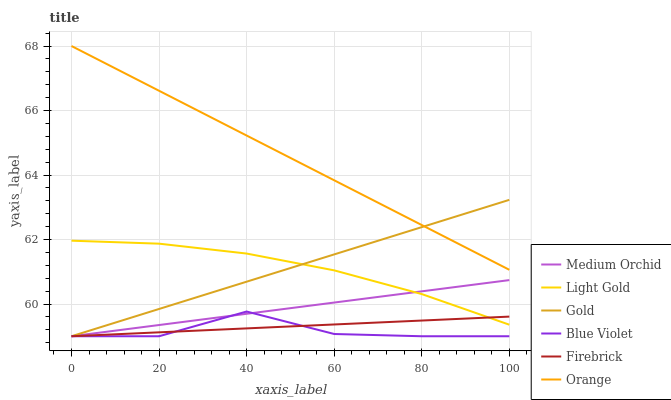Does Blue Violet have the minimum area under the curve?
Answer yes or no. Yes. Does Orange have the maximum area under the curve?
Answer yes or no. Yes. Does Firebrick have the minimum area under the curve?
Answer yes or no. No. Does Firebrick have the maximum area under the curve?
Answer yes or no. No. Is Gold the smoothest?
Answer yes or no. Yes. Is Blue Violet the roughest?
Answer yes or no. Yes. Is Firebrick the smoothest?
Answer yes or no. No. Is Firebrick the roughest?
Answer yes or no. No. Does Gold have the lowest value?
Answer yes or no. Yes. Does Orange have the lowest value?
Answer yes or no. No. Does Orange have the highest value?
Answer yes or no. Yes. Does Medium Orchid have the highest value?
Answer yes or no. No. Is Medium Orchid less than Orange?
Answer yes or no. Yes. Is Orange greater than Firebrick?
Answer yes or no. Yes. Does Gold intersect Medium Orchid?
Answer yes or no. Yes. Is Gold less than Medium Orchid?
Answer yes or no. No. Is Gold greater than Medium Orchid?
Answer yes or no. No. Does Medium Orchid intersect Orange?
Answer yes or no. No. 